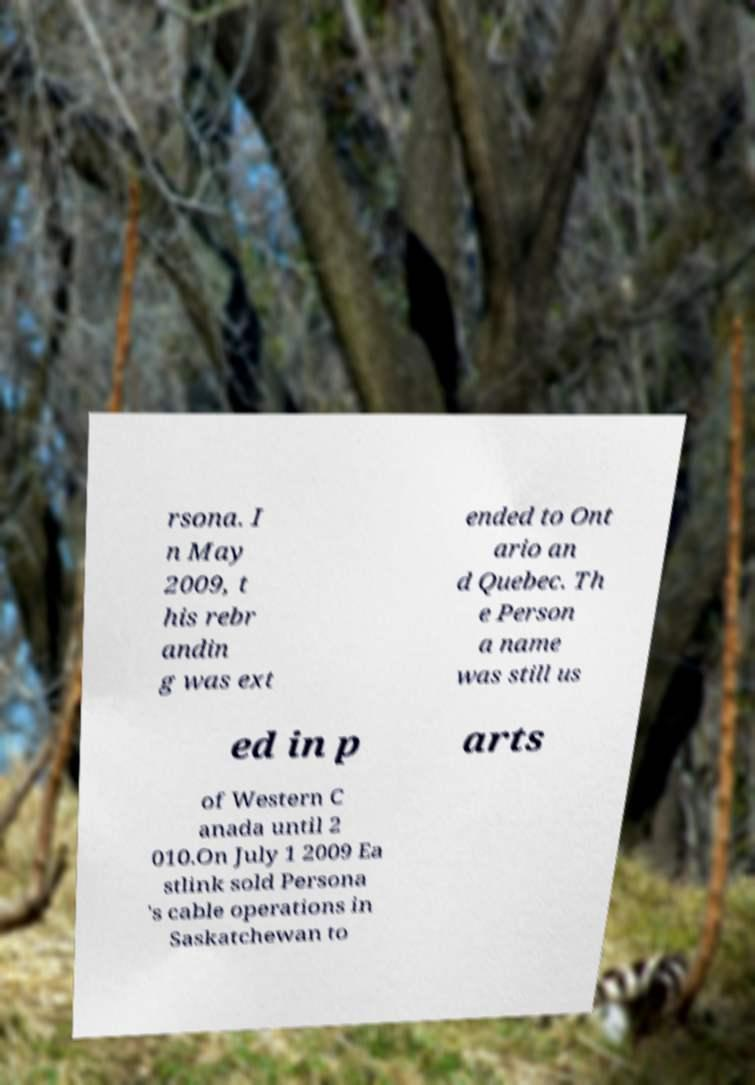Can you read and provide the text displayed in the image?This photo seems to have some interesting text. Can you extract and type it out for me? rsona. I n May 2009, t his rebr andin g was ext ended to Ont ario an d Quebec. Th e Person a name was still us ed in p arts of Western C anada until 2 010.On July 1 2009 Ea stlink sold Persona 's cable operations in Saskatchewan to 